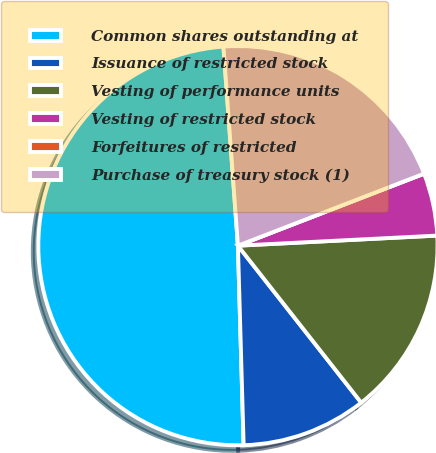Convert chart. <chart><loc_0><loc_0><loc_500><loc_500><pie_chart><fcel>Common shares outstanding at<fcel>Issuance of restricted stock<fcel>Vesting of performance units<fcel>Vesting of restricted stock<fcel>Forfeitures of restricted<fcel>Purchase of treasury stock (1)<nl><fcel>49.3%<fcel>10.14%<fcel>15.21%<fcel>5.07%<fcel>0.0%<fcel>20.28%<nl></chart> 